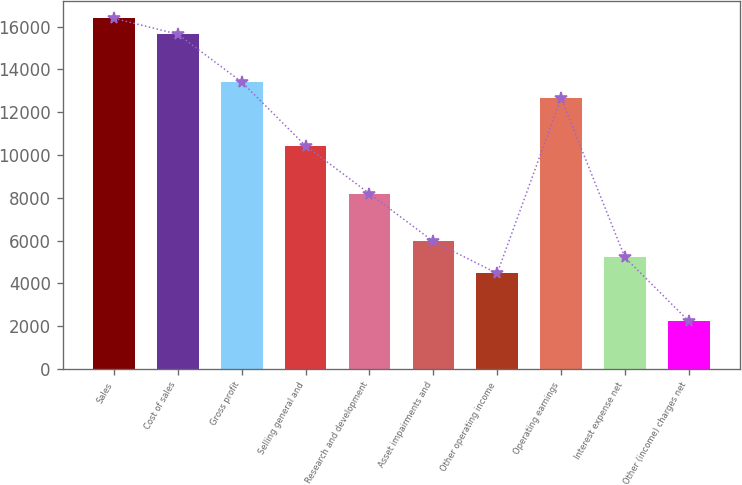Convert chart to OTSL. <chart><loc_0><loc_0><loc_500><loc_500><bar_chart><fcel>Sales<fcel>Cost of sales<fcel>Gross profit<fcel>Selling general and<fcel>Research and development<fcel>Asset impairments and<fcel>Other operating income<fcel>Operating earnings<fcel>Interest expense net<fcel>Other (income) charges net<nl><fcel>16388.8<fcel>15643.9<fcel>13409.2<fcel>10429.6<fcel>8194.9<fcel>5960.2<fcel>4470.4<fcel>12664.3<fcel>5215.3<fcel>2235.7<nl></chart> 